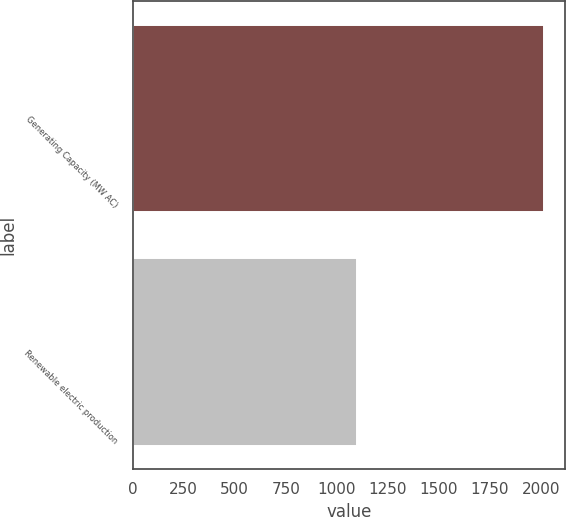Convert chart. <chart><loc_0><loc_0><loc_500><loc_500><bar_chart><fcel>Generating Capacity (MW AC)<fcel>Renewable electric production<nl><fcel>2016<fcel>1098<nl></chart> 